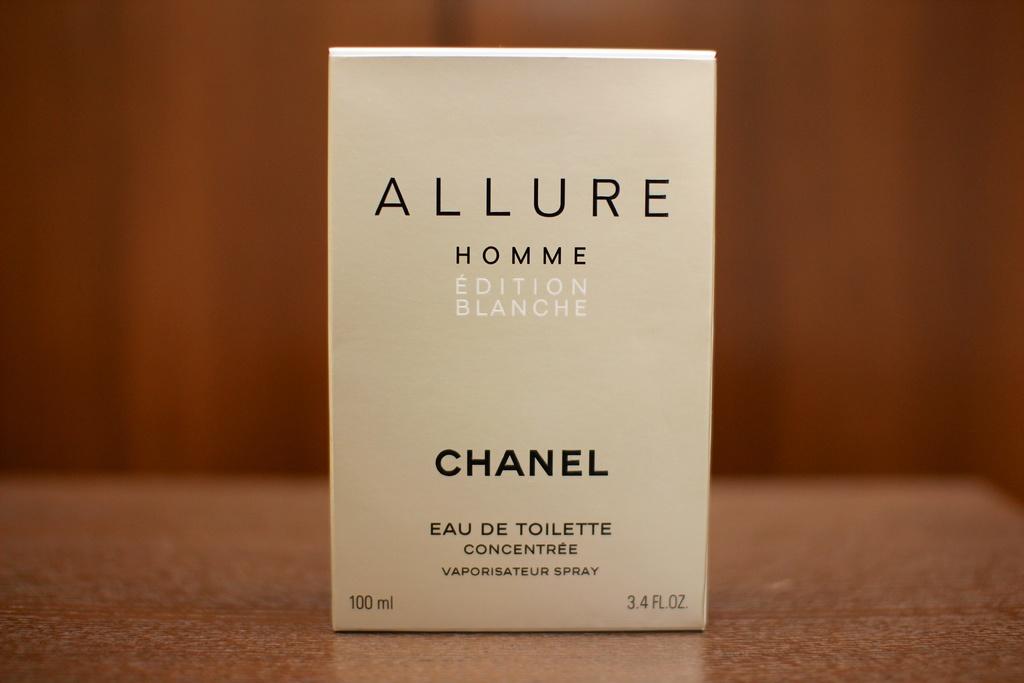What is the name of the fragrance?
Your response must be concise. Allure. What is the size?
Provide a short and direct response. 100 ml. 